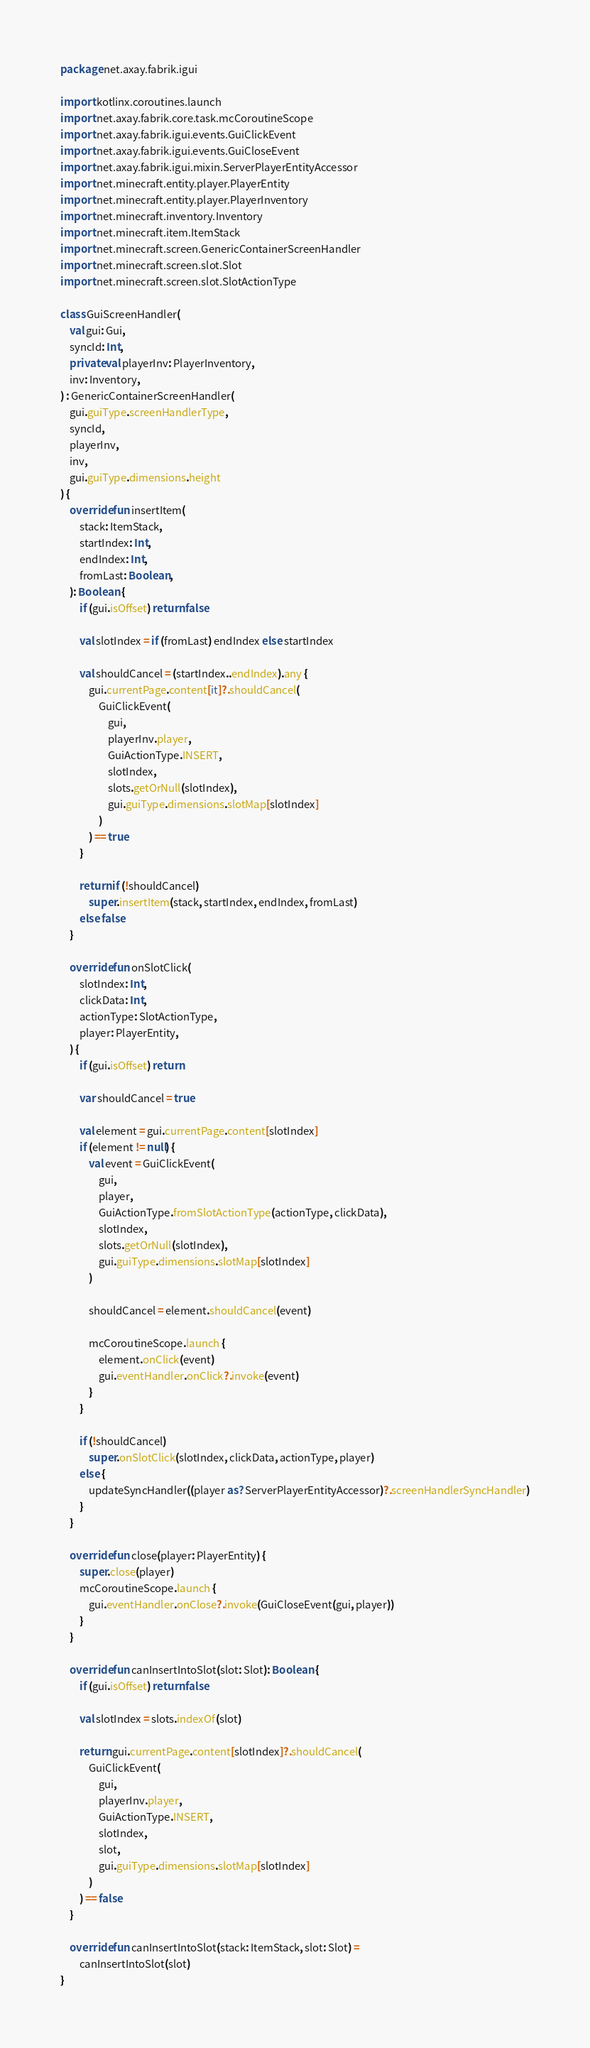Convert code to text. <code><loc_0><loc_0><loc_500><loc_500><_Kotlin_>package net.axay.fabrik.igui

import kotlinx.coroutines.launch
import net.axay.fabrik.core.task.mcCoroutineScope
import net.axay.fabrik.igui.events.GuiClickEvent
import net.axay.fabrik.igui.events.GuiCloseEvent
import net.axay.fabrik.igui.mixin.ServerPlayerEntityAccessor
import net.minecraft.entity.player.PlayerEntity
import net.minecraft.entity.player.PlayerInventory
import net.minecraft.inventory.Inventory
import net.minecraft.item.ItemStack
import net.minecraft.screen.GenericContainerScreenHandler
import net.minecraft.screen.slot.Slot
import net.minecraft.screen.slot.SlotActionType

class GuiScreenHandler(
    val gui: Gui,
    syncId: Int,
    private val playerInv: PlayerInventory,
    inv: Inventory,
) : GenericContainerScreenHandler(
    gui.guiType.screenHandlerType,
    syncId,
    playerInv,
    inv,
    gui.guiType.dimensions.height
) {
    override fun insertItem(
        stack: ItemStack,
        startIndex: Int,
        endIndex: Int,
        fromLast: Boolean,
    ): Boolean {
        if (gui.isOffset) return false

        val slotIndex = if (fromLast) endIndex else startIndex

        val shouldCancel = (startIndex..endIndex).any {
            gui.currentPage.content[it]?.shouldCancel(
                GuiClickEvent(
                    gui,
                    playerInv.player,
                    GuiActionType.INSERT,
                    slotIndex,
                    slots.getOrNull(slotIndex),
                    gui.guiType.dimensions.slotMap[slotIndex]
                )
            ) == true
        }

        return if (!shouldCancel)
            super.insertItem(stack, startIndex, endIndex, fromLast)
        else false
    }

    override fun onSlotClick(
        slotIndex: Int,
        clickData: Int,
        actionType: SlotActionType,
        player: PlayerEntity,
    ) {
        if (gui.isOffset) return

        var shouldCancel = true

        val element = gui.currentPage.content[slotIndex]
        if (element != null) {
            val event = GuiClickEvent(
                gui,
                player,
                GuiActionType.fromSlotActionType(actionType, clickData),
                slotIndex,
                slots.getOrNull(slotIndex),
                gui.guiType.dimensions.slotMap[slotIndex]
            )

            shouldCancel = element.shouldCancel(event)

            mcCoroutineScope.launch {
                element.onClick(event)
                gui.eventHandler.onClick?.invoke(event)
            }
        }

        if (!shouldCancel)
            super.onSlotClick(slotIndex, clickData, actionType, player)
        else {
            updateSyncHandler((player as? ServerPlayerEntityAccessor)?.screenHandlerSyncHandler)
        }
    }

    override fun close(player: PlayerEntity) {
        super.close(player)
        mcCoroutineScope.launch {
            gui.eventHandler.onClose?.invoke(GuiCloseEvent(gui, player))
        }
    }

    override fun canInsertIntoSlot(slot: Slot): Boolean {
        if (gui.isOffset) return false

        val slotIndex = slots.indexOf(slot)

        return gui.currentPage.content[slotIndex]?.shouldCancel(
            GuiClickEvent(
                gui,
                playerInv.player,
                GuiActionType.INSERT,
                slotIndex,
                slot,
                gui.guiType.dimensions.slotMap[slotIndex]
            )
        ) == false
    }

    override fun canInsertIntoSlot(stack: ItemStack, slot: Slot) =
        canInsertIntoSlot(slot)
}
</code> 